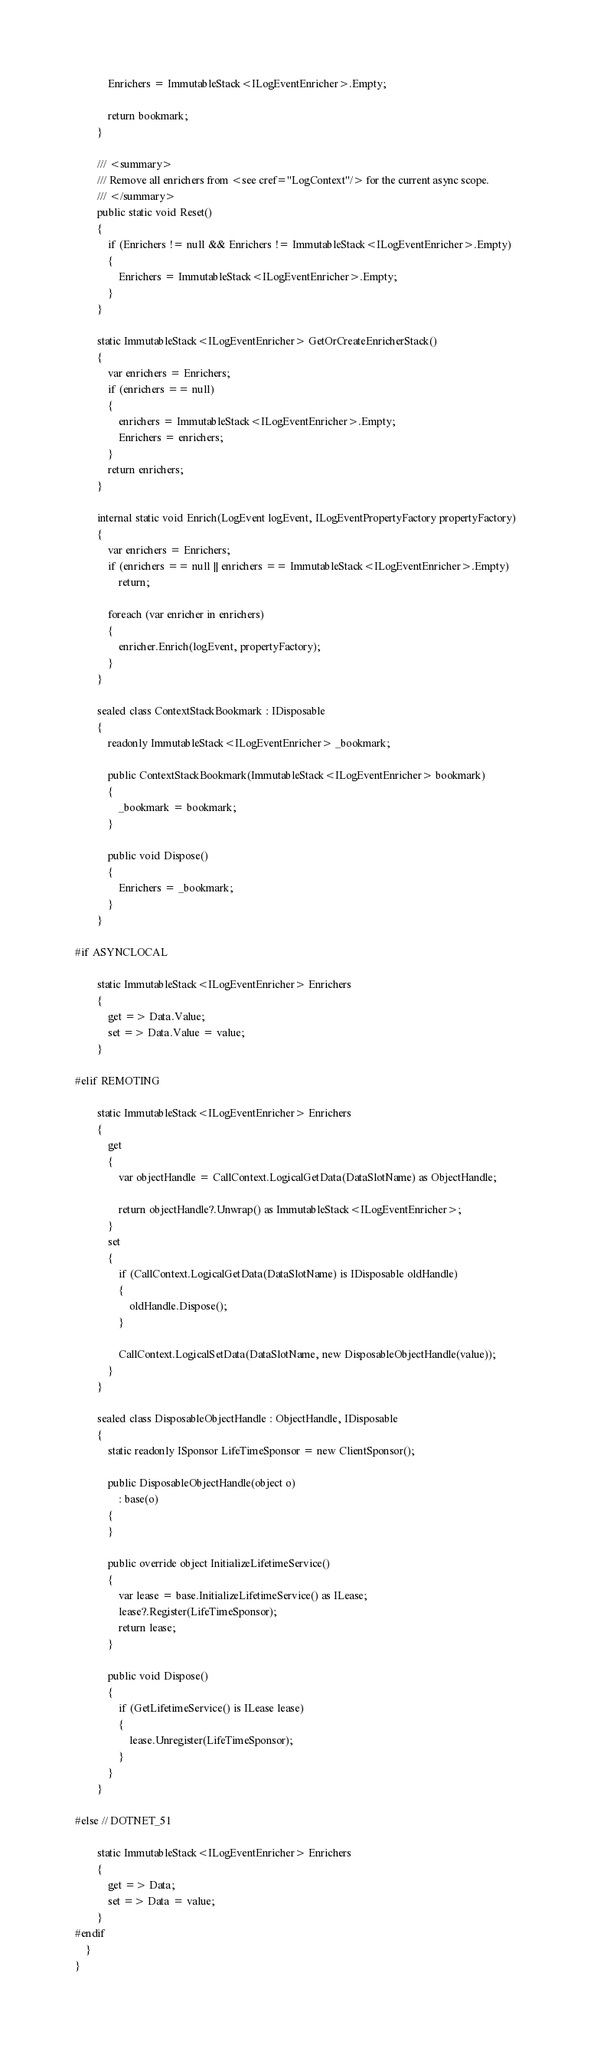Convert code to text. <code><loc_0><loc_0><loc_500><loc_500><_C#_>
            Enrichers = ImmutableStack<ILogEventEnricher>.Empty;

            return bookmark;
        }

        /// <summary>
        /// Remove all enrichers from <see cref="LogContext"/> for the current async scope.
        /// </summary>
        public static void Reset()
        {
            if (Enrichers != null && Enrichers != ImmutableStack<ILogEventEnricher>.Empty)
            {
                Enrichers = ImmutableStack<ILogEventEnricher>.Empty;
            }
        }

        static ImmutableStack<ILogEventEnricher> GetOrCreateEnricherStack()
        {
            var enrichers = Enrichers;
            if (enrichers == null)
            {
                enrichers = ImmutableStack<ILogEventEnricher>.Empty;
                Enrichers = enrichers;
            }
            return enrichers;
        }

        internal static void Enrich(LogEvent logEvent, ILogEventPropertyFactory propertyFactory)
        {
            var enrichers = Enrichers;
            if (enrichers == null || enrichers == ImmutableStack<ILogEventEnricher>.Empty)
                return;

            foreach (var enricher in enrichers)
            {
                enricher.Enrich(logEvent, propertyFactory);
            }
        }

        sealed class ContextStackBookmark : IDisposable
        {
            readonly ImmutableStack<ILogEventEnricher> _bookmark;

            public ContextStackBookmark(ImmutableStack<ILogEventEnricher> bookmark)
            {
                _bookmark = bookmark;
            }

            public void Dispose()
            {
                Enrichers = _bookmark;
            }
        }

#if ASYNCLOCAL

        static ImmutableStack<ILogEventEnricher> Enrichers
        {
            get => Data.Value;
            set => Data.Value = value;
        }

#elif REMOTING

        static ImmutableStack<ILogEventEnricher> Enrichers
        {
            get
            {
                var objectHandle = CallContext.LogicalGetData(DataSlotName) as ObjectHandle;

                return objectHandle?.Unwrap() as ImmutableStack<ILogEventEnricher>;
            }
            set
            {
                if (CallContext.LogicalGetData(DataSlotName) is IDisposable oldHandle)
                {
                    oldHandle.Dispose();
                }

                CallContext.LogicalSetData(DataSlotName, new DisposableObjectHandle(value));
            }
        }

        sealed class DisposableObjectHandle : ObjectHandle, IDisposable
        {
            static readonly ISponsor LifeTimeSponsor = new ClientSponsor();

            public DisposableObjectHandle(object o)
                : base(o)
            {
            }

            public override object InitializeLifetimeService()
            {
                var lease = base.InitializeLifetimeService() as ILease;
                lease?.Register(LifeTimeSponsor);
                return lease;
            }

            public void Dispose()
            {
                if (GetLifetimeService() is ILease lease)
                {
                    lease.Unregister(LifeTimeSponsor);
                }
            }
        }

#else // DOTNET_51

        static ImmutableStack<ILogEventEnricher> Enrichers
        {
            get => Data;
            set => Data = value;
        }
#endif
    }
}
</code> 